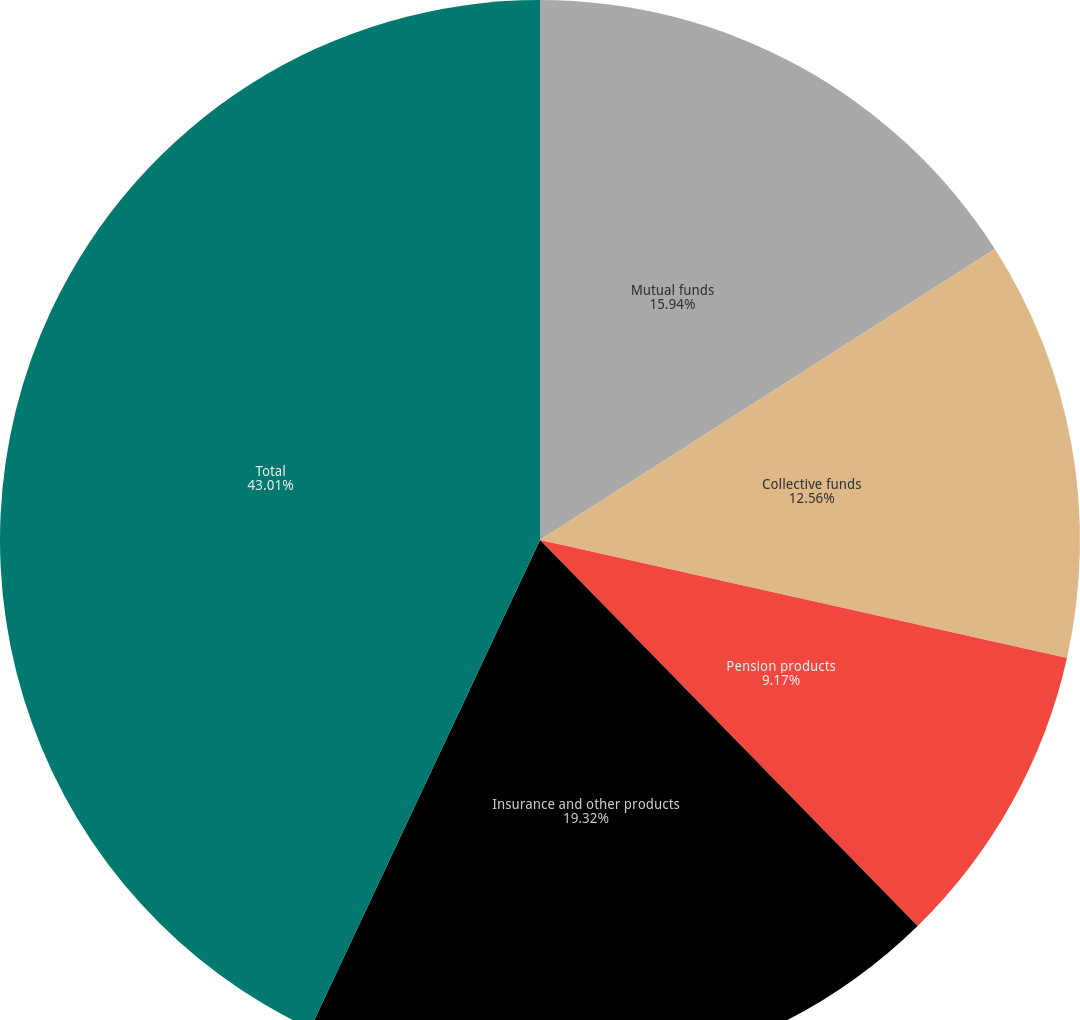Convert chart. <chart><loc_0><loc_0><loc_500><loc_500><pie_chart><fcel>Mutual funds<fcel>Collective funds<fcel>Pension products<fcel>Insurance and other products<fcel>Total<nl><fcel>15.94%<fcel>12.56%<fcel>9.17%<fcel>19.32%<fcel>43.0%<nl></chart> 